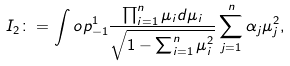<formula> <loc_0><loc_0><loc_500><loc_500>I _ { 2 } \colon = \int o p _ { - 1 } ^ { 1 } \frac { \prod _ { i = 1 } ^ { n } \mu _ { i } d \mu _ { i } } { \sqrt { 1 - \sum _ { i = 1 } ^ { n } \mu _ { i } ^ { 2 } } } \sum _ { j = 1 } ^ { n } \alpha _ { j } \mu _ { j } ^ { 2 } ,</formula> 